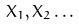<formula> <loc_0><loc_0><loc_500><loc_500>X _ { 1 } , X _ { 2 } \dots</formula> 